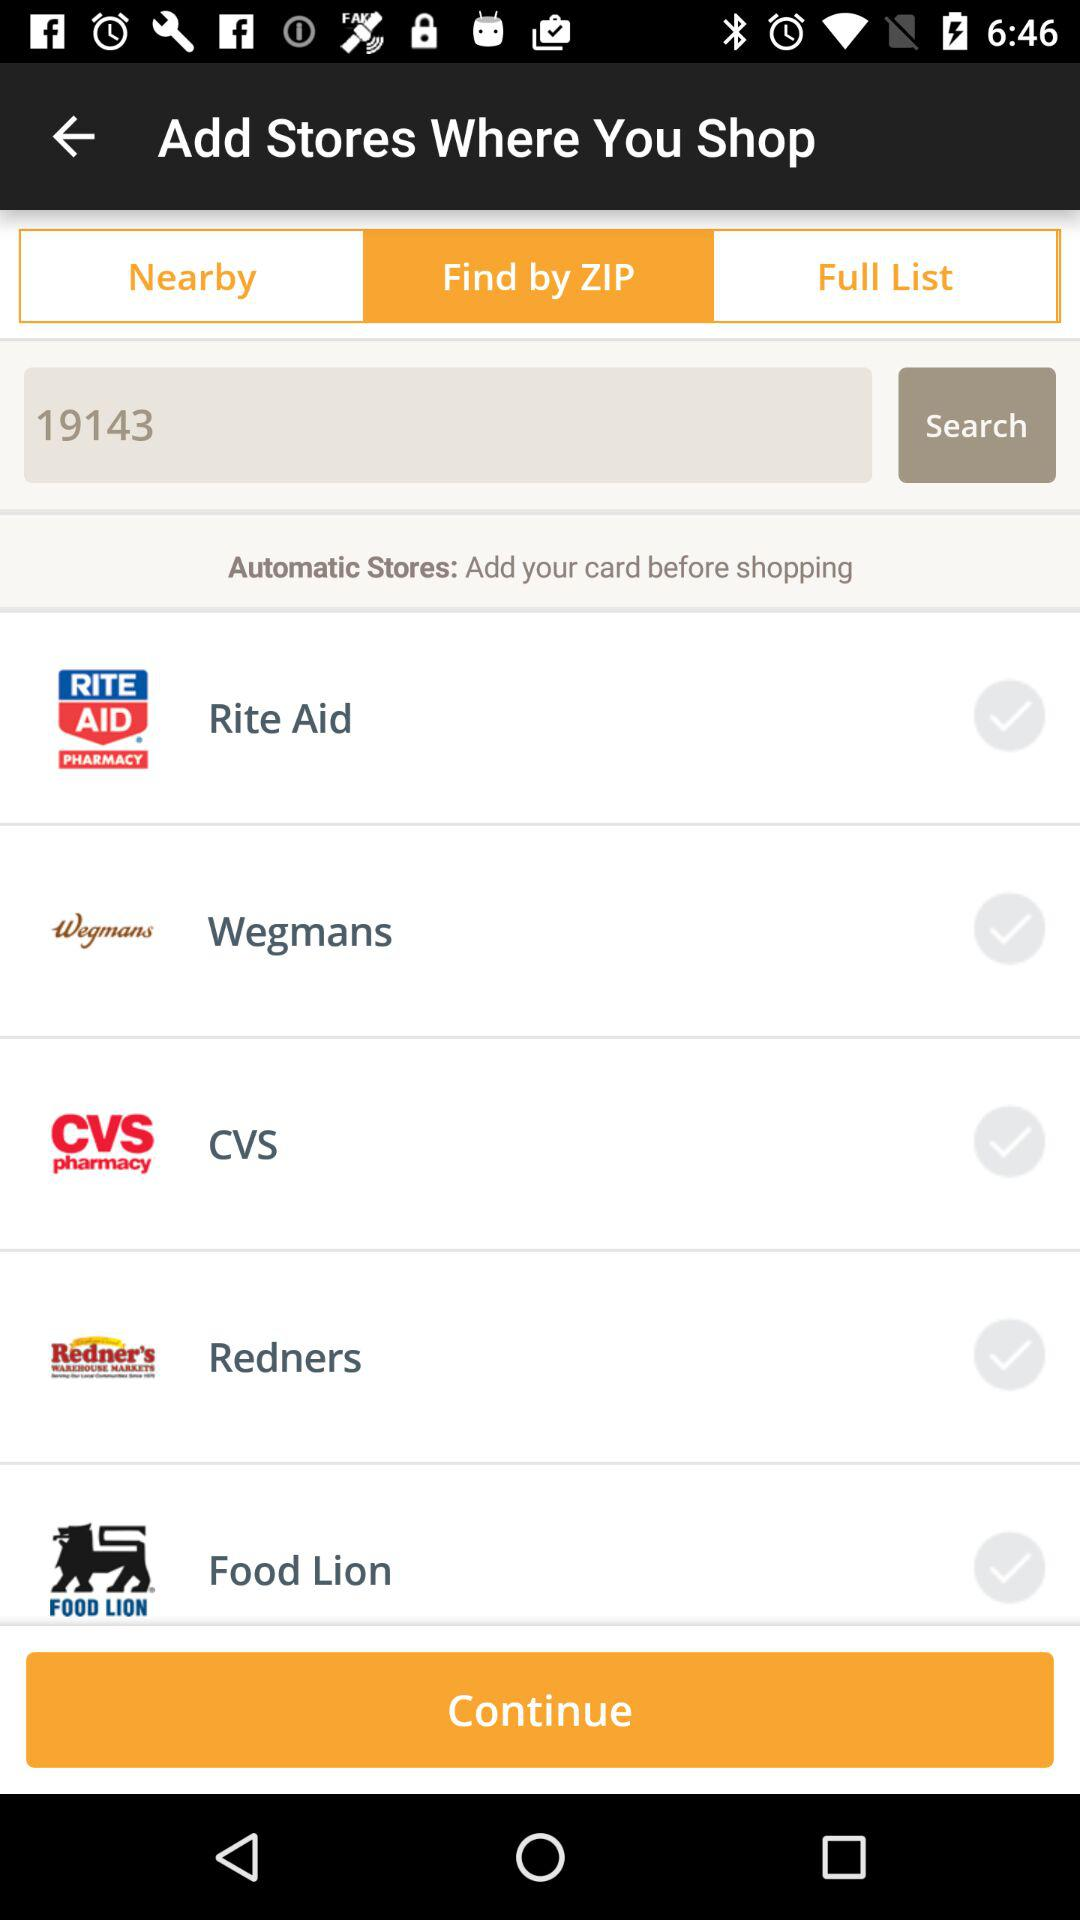Which tab am I on? You are on the "Find by ZIP" tab. 